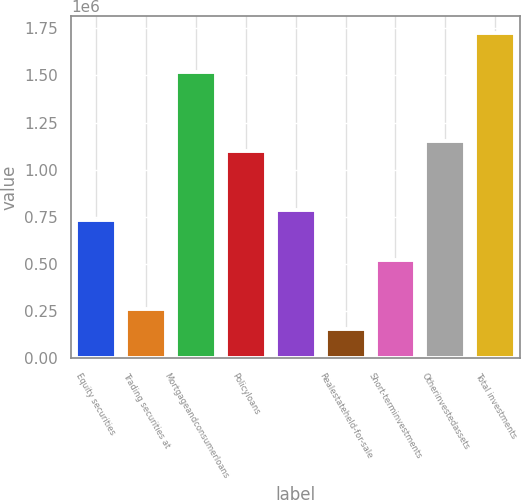Convert chart. <chart><loc_0><loc_0><loc_500><loc_500><bar_chart><fcel>Equity securities<fcel>Trading securities at<fcel>Mortgageandconsumerloans<fcel>Policyloans<fcel>Unnamed: 4<fcel>Realestateheld-for-sale<fcel>Short-terminvestments<fcel>Otherinvestedassets<fcel>Total investments<nl><fcel>732736<fcel>261692<fcel>1.51781e+06<fcel>1.0991e+06<fcel>785074<fcel>157016<fcel>523383<fcel>1.15144e+06<fcel>1.72716e+06<nl></chart> 